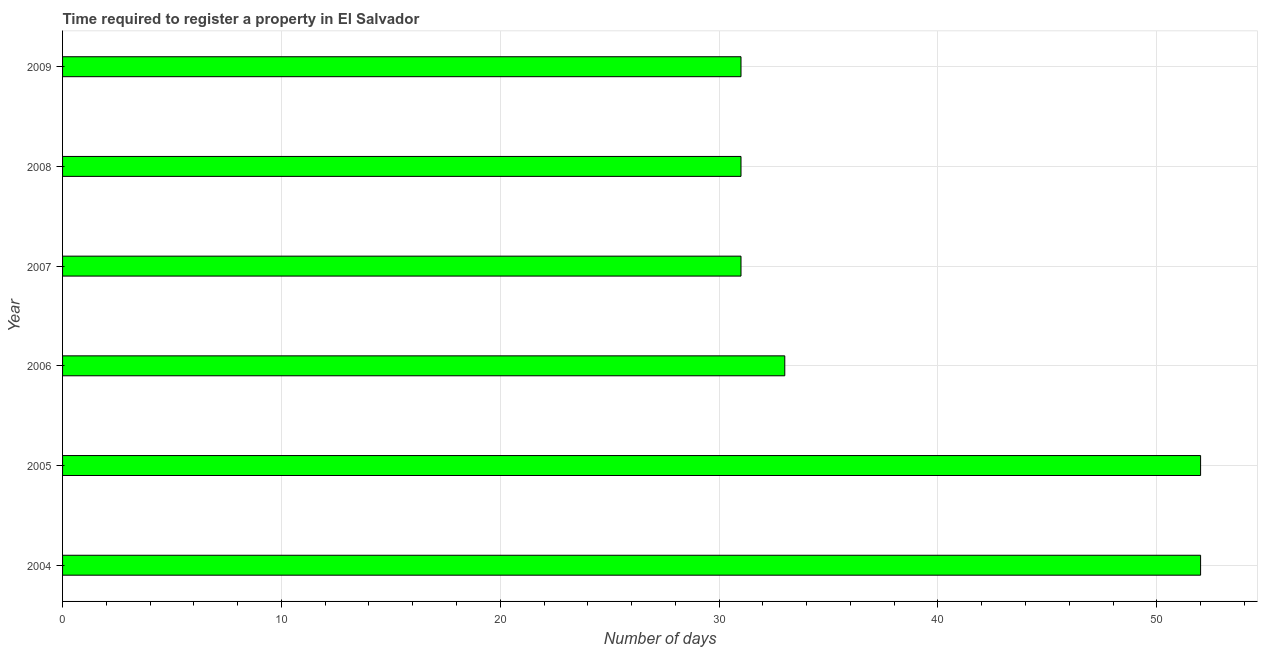Does the graph contain any zero values?
Ensure brevity in your answer.  No. Does the graph contain grids?
Offer a very short reply. Yes. What is the title of the graph?
Provide a short and direct response. Time required to register a property in El Salvador. What is the label or title of the X-axis?
Give a very brief answer. Number of days. What is the label or title of the Y-axis?
Your response must be concise. Year. What is the number of days required to register property in 2009?
Your answer should be compact. 31. In which year was the number of days required to register property minimum?
Provide a succinct answer. 2007. What is the sum of the number of days required to register property?
Provide a succinct answer. 230. What is the difference between the number of days required to register property in 2005 and 2007?
Your response must be concise. 21. What is the median number of days required to register property?
Ensure brevity in your answer.  32. Is the number of days required to register property in 2006 less than that in 2007?
Your response must be concise. No. Is the difference between the number of days required to register property in 2005 and 2008 greater than the difference between any two years?
Offer a terse response. Yes. What is the difference between the highest and the second highest number of days required to register property?
Your answer should be very brief. 0. Are the values on the major ticks of X-axis written in scientific E-notation?
Provide a succinct answer. No. What is the Number of days of 2008?
Provide a short and direct response. 31. What is the Number of days in 2009?
Your answer should be compact. 31. What is the difference between the Number of days in 2004 and 2007?
Give a very brief answer. 21. What is the difference between the Number of days in 2004 and 2009?
Provide a succinct answer. 21. What is the difference between the Number of days in 2005 and 2007?
Ensure brevity in your answer.  21. What is the difference between the Number of days in 2005 and 2009?
Offer a very short reply. 21. What is the difference between the Number of days in 2008 and 2009?
Provide a short and direct response. 0. What is the ratio of the Number of days in 2004 to that in 2005?
Provide a succinct answer. 1. What is the ratio of the Number of days in 2004 to that in 2006?
Your response must be concise. 1.58. What is the ratio of the Number of days in 2004 to that in 2007?
Ensure brevity in your answer.  1.68. What is the ratio of the Number of days in 2004 to that in 2008?
Your answer should be compact. 1.68. What is the ratio of the Number of days in 2004 to that in 2009?
Ensure brevity in your answer.  1.68. What is the ratio of the Number of days in 2005 to that in 2006?
Keep it short and to the point. 1.58. What is the ratio of the Number of days in 2005 to that in 2007?
Your answer should be very brief. 1.68. What is the ratio of the Number of days in 2005 to that in 2008?
Give a very brief answer. 1.68. What is the ratio of the Number of days in 2005 to that in 2009?
Provide a succinct answer. 1.68. What is the ratio of the Number of days in 2006 to that in 2007?
Provide a succinct answer. 1.06. What is the ratio of the Number of days in 2006 to that in 2008?
Offer a very short reply. 1.06. What is the ratio of the Number of days in 2006 to that in 2009?
Your response must be concise. 1.06. What is the ratio of the Number of days in 2007 to that in 2009?
Your answer should be compact. 1. What is the ratio of the Number of days in 2008 to that in 2009?
Provide a short and direct response. 1. 